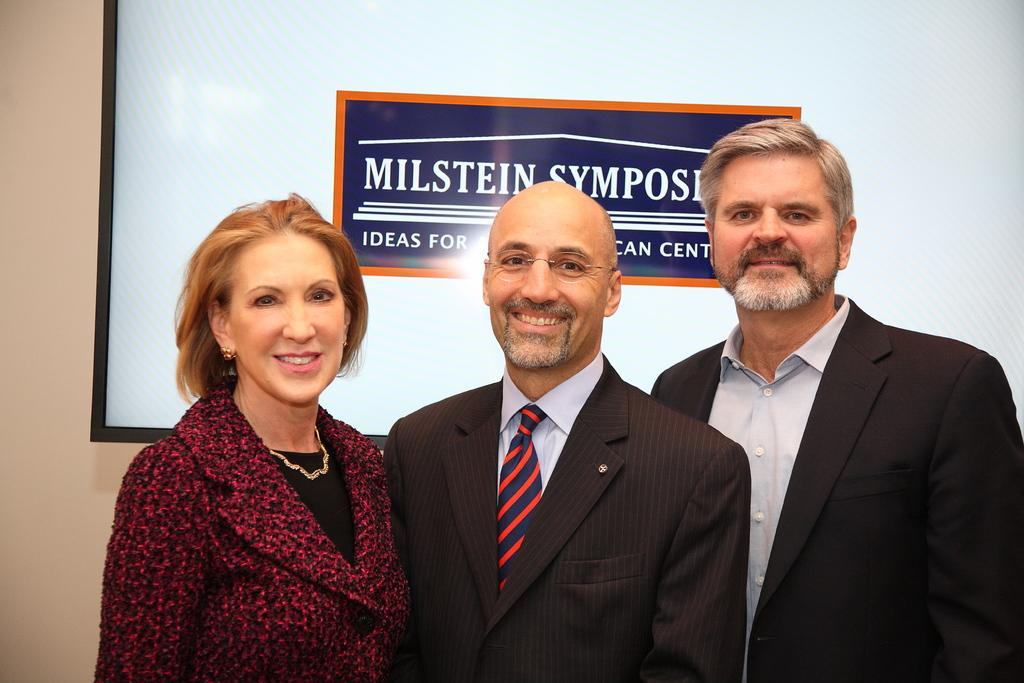How many people are in the image? There are two men and one woman in the image. What are the men wearing? The men are wearing blazers. What is the woman doing in the image? The woman is standing and smiling. What can be seen in the background of the image? There is a wall and a huge board attached to the wall in the background. What note is the cook playing in the image? There is no cook or musical instrument present in the image. 